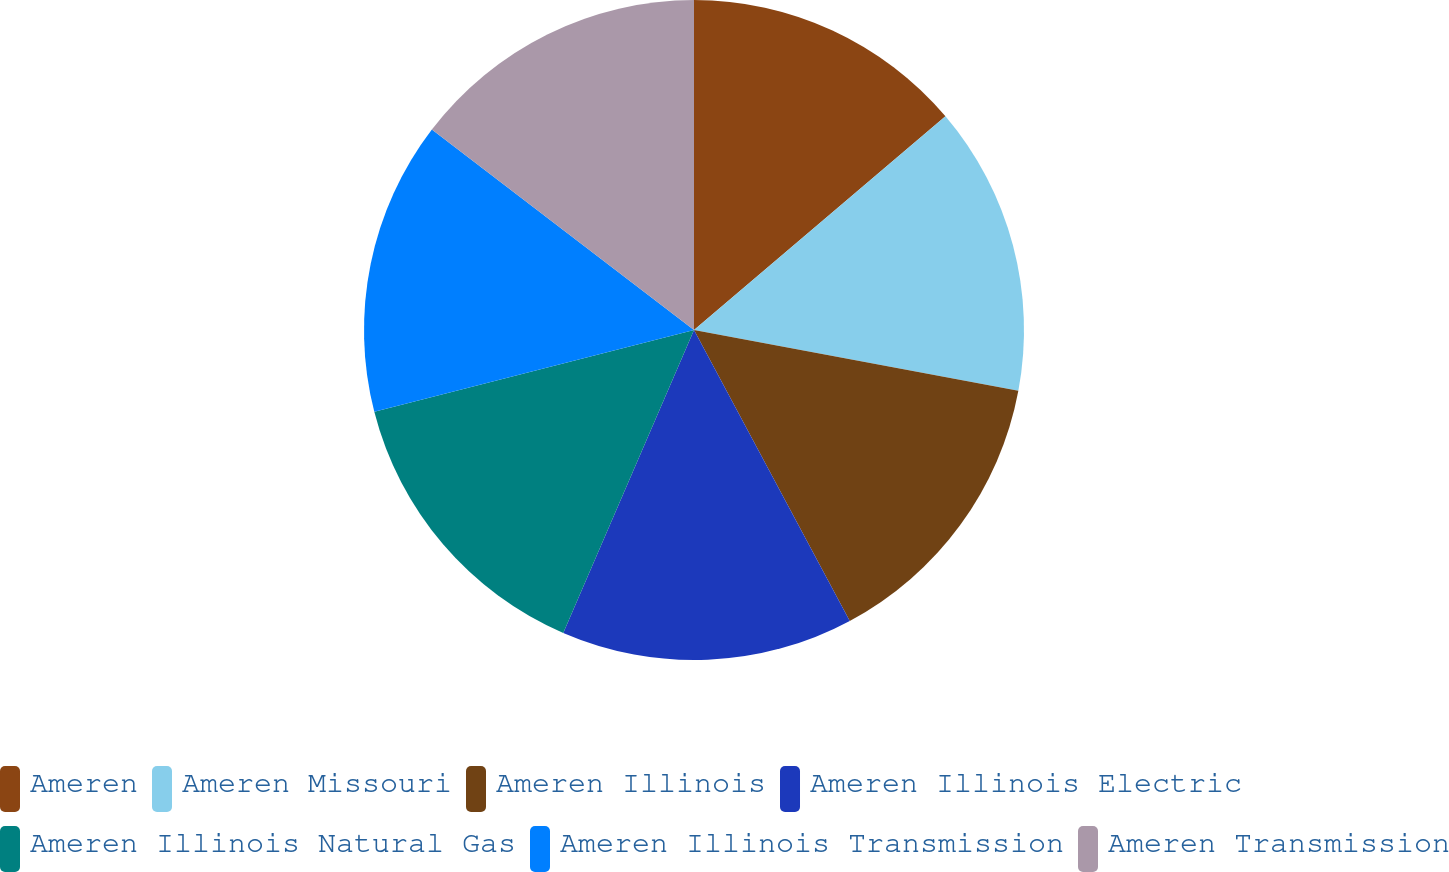Convert chart. <chart><loc_0><loc_0><loc_500><loc_500><pie_chart><fcel>Ameren<fcel>Ameren Missouri<fcel>Ameren Illinois<fcel>Ameren Illinois Electric<fcel>Ameren Illinois Natural Gas<fcel>Ameren Illinois Transmission<fcel>Ameren Transmission<nl><fcel>13.79%<fcel>14.16%<fcel>14.23%<fcel>14.31%<fcel>14.53%<fcel>14.38%<fcel>14.61%<nl></chart> 